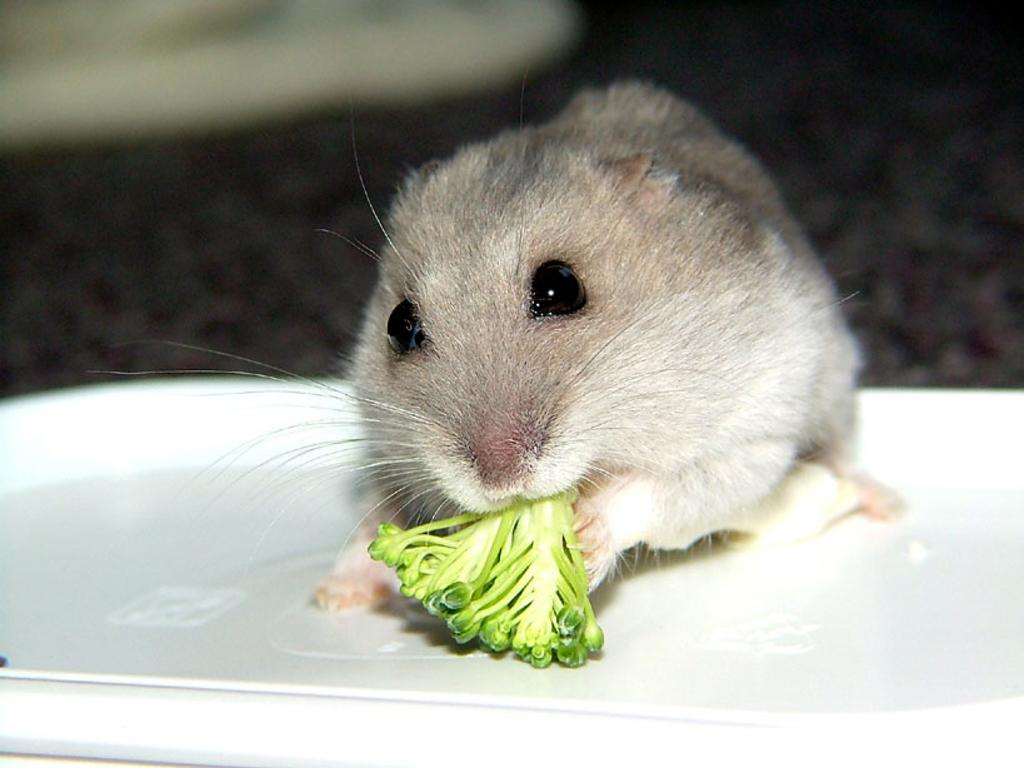What animal is present in the image? There is a rat in the image. What is the rat doing in the image? The rat is eating food in the image. Where is the rat located in the image? The rat is on a plate in the image. Can you describe the background of the image? The background of the image is blurred. What is the rat's tendency to jump in the image? There is no indication of the rat jumping in the image; it is shown eating food while on a plate. 